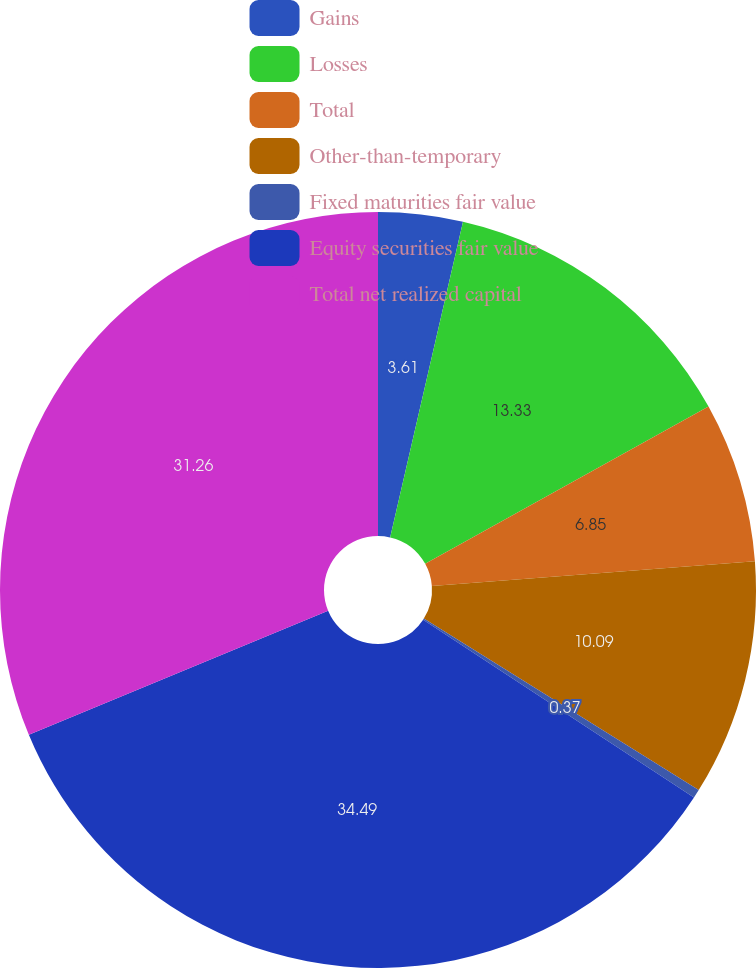<chart> <loc_0><loc_0><loc_500><loc_500><pie_chart><fcel>Gains<fcel>Losses<fcel>Total<fcel>Other-than-temporary<fcel>Fixed maturities fair value<fcel>Equity securities fair value<fcel>Total net realized capital<nl><fcel>3.61%<fcel>13.33%<fcel>6.85%<fcel>10.09%<fcel>0.37%<fcel>34.5%<fcel>31.26%<nl></chart> 